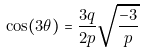Convert formula to latex. <formula><loc_0><loc_0><loc_500><loc_500>\cos ( 3 \theta ) = \frac { 3 q } { 2 p } \sqrt { \frac { - 3 } { p } }</formula> 